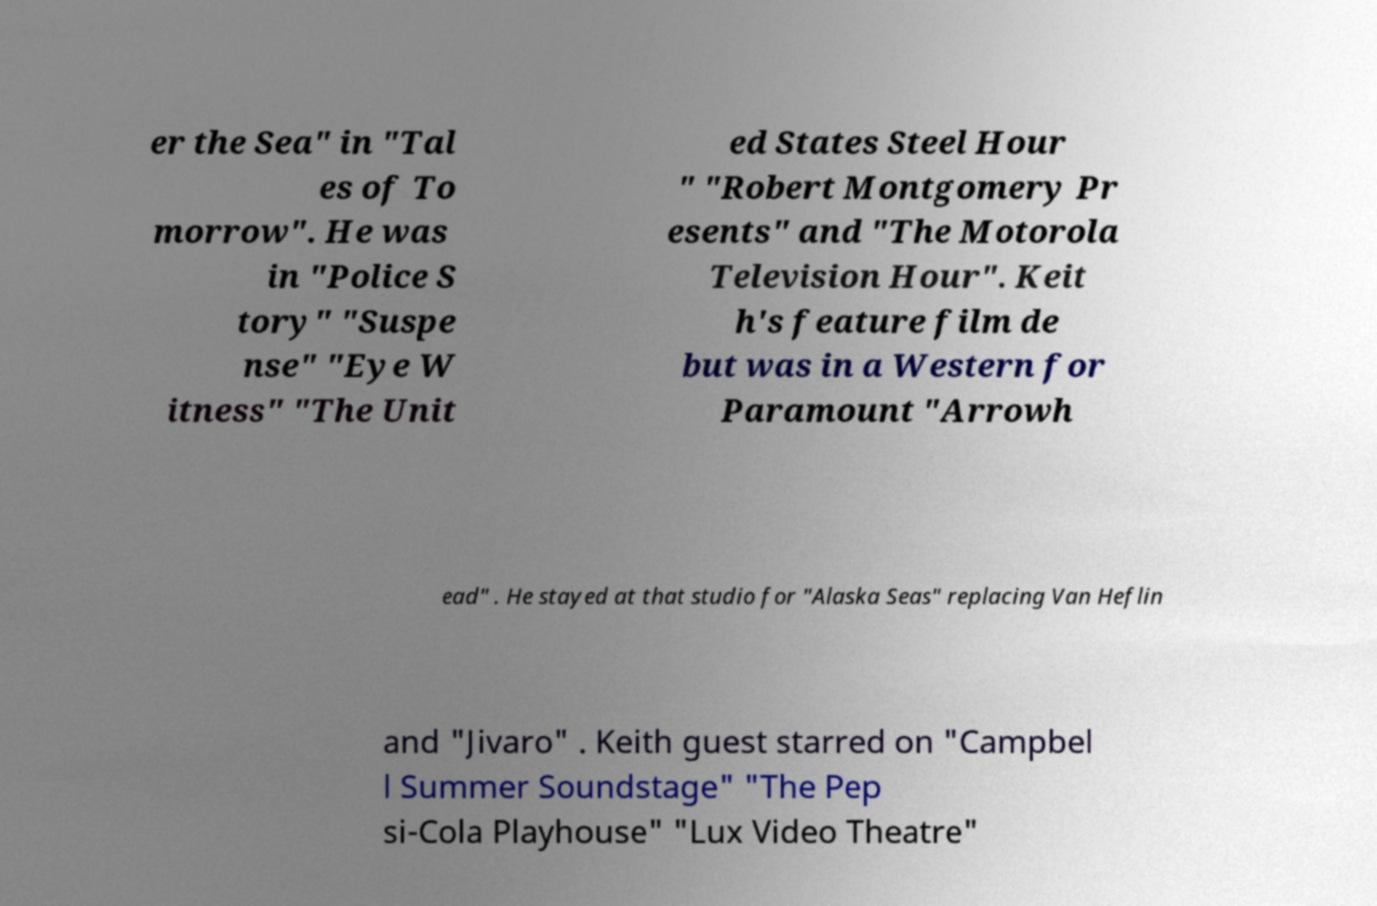Can you accurately transcribe the text from the provided image for me? er the Sea" in "Tal es of To morrow". He was in "Police S tory" "Suspe nse" "Eye W itness" "The Unit ed States Steel Hour " "Robert Montgomery Pr esents" and "The Motorola Television Hour". Keit h's feature film de but was in a Western for Paramount "Arrowh ead" . He stayed at that studio for "Alaska Seas" replacing Van Heflin and "Jivaro" . Keith guest starred on "Campbel l Summer Soundstage" "The Pep si-Cola Playhouse" "Lux Video Theatre" 